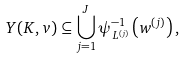<formula> <loc_0><loc_0><loc_500><loc_500>Y ( K , v ) \subseteq \bigcup _ { j = 1 } ^ { J } \psi _ { L ^ { ( j ) } } ^ { - 1 } \left ( w ^ { ( j ) } \right ) ,</formula> 